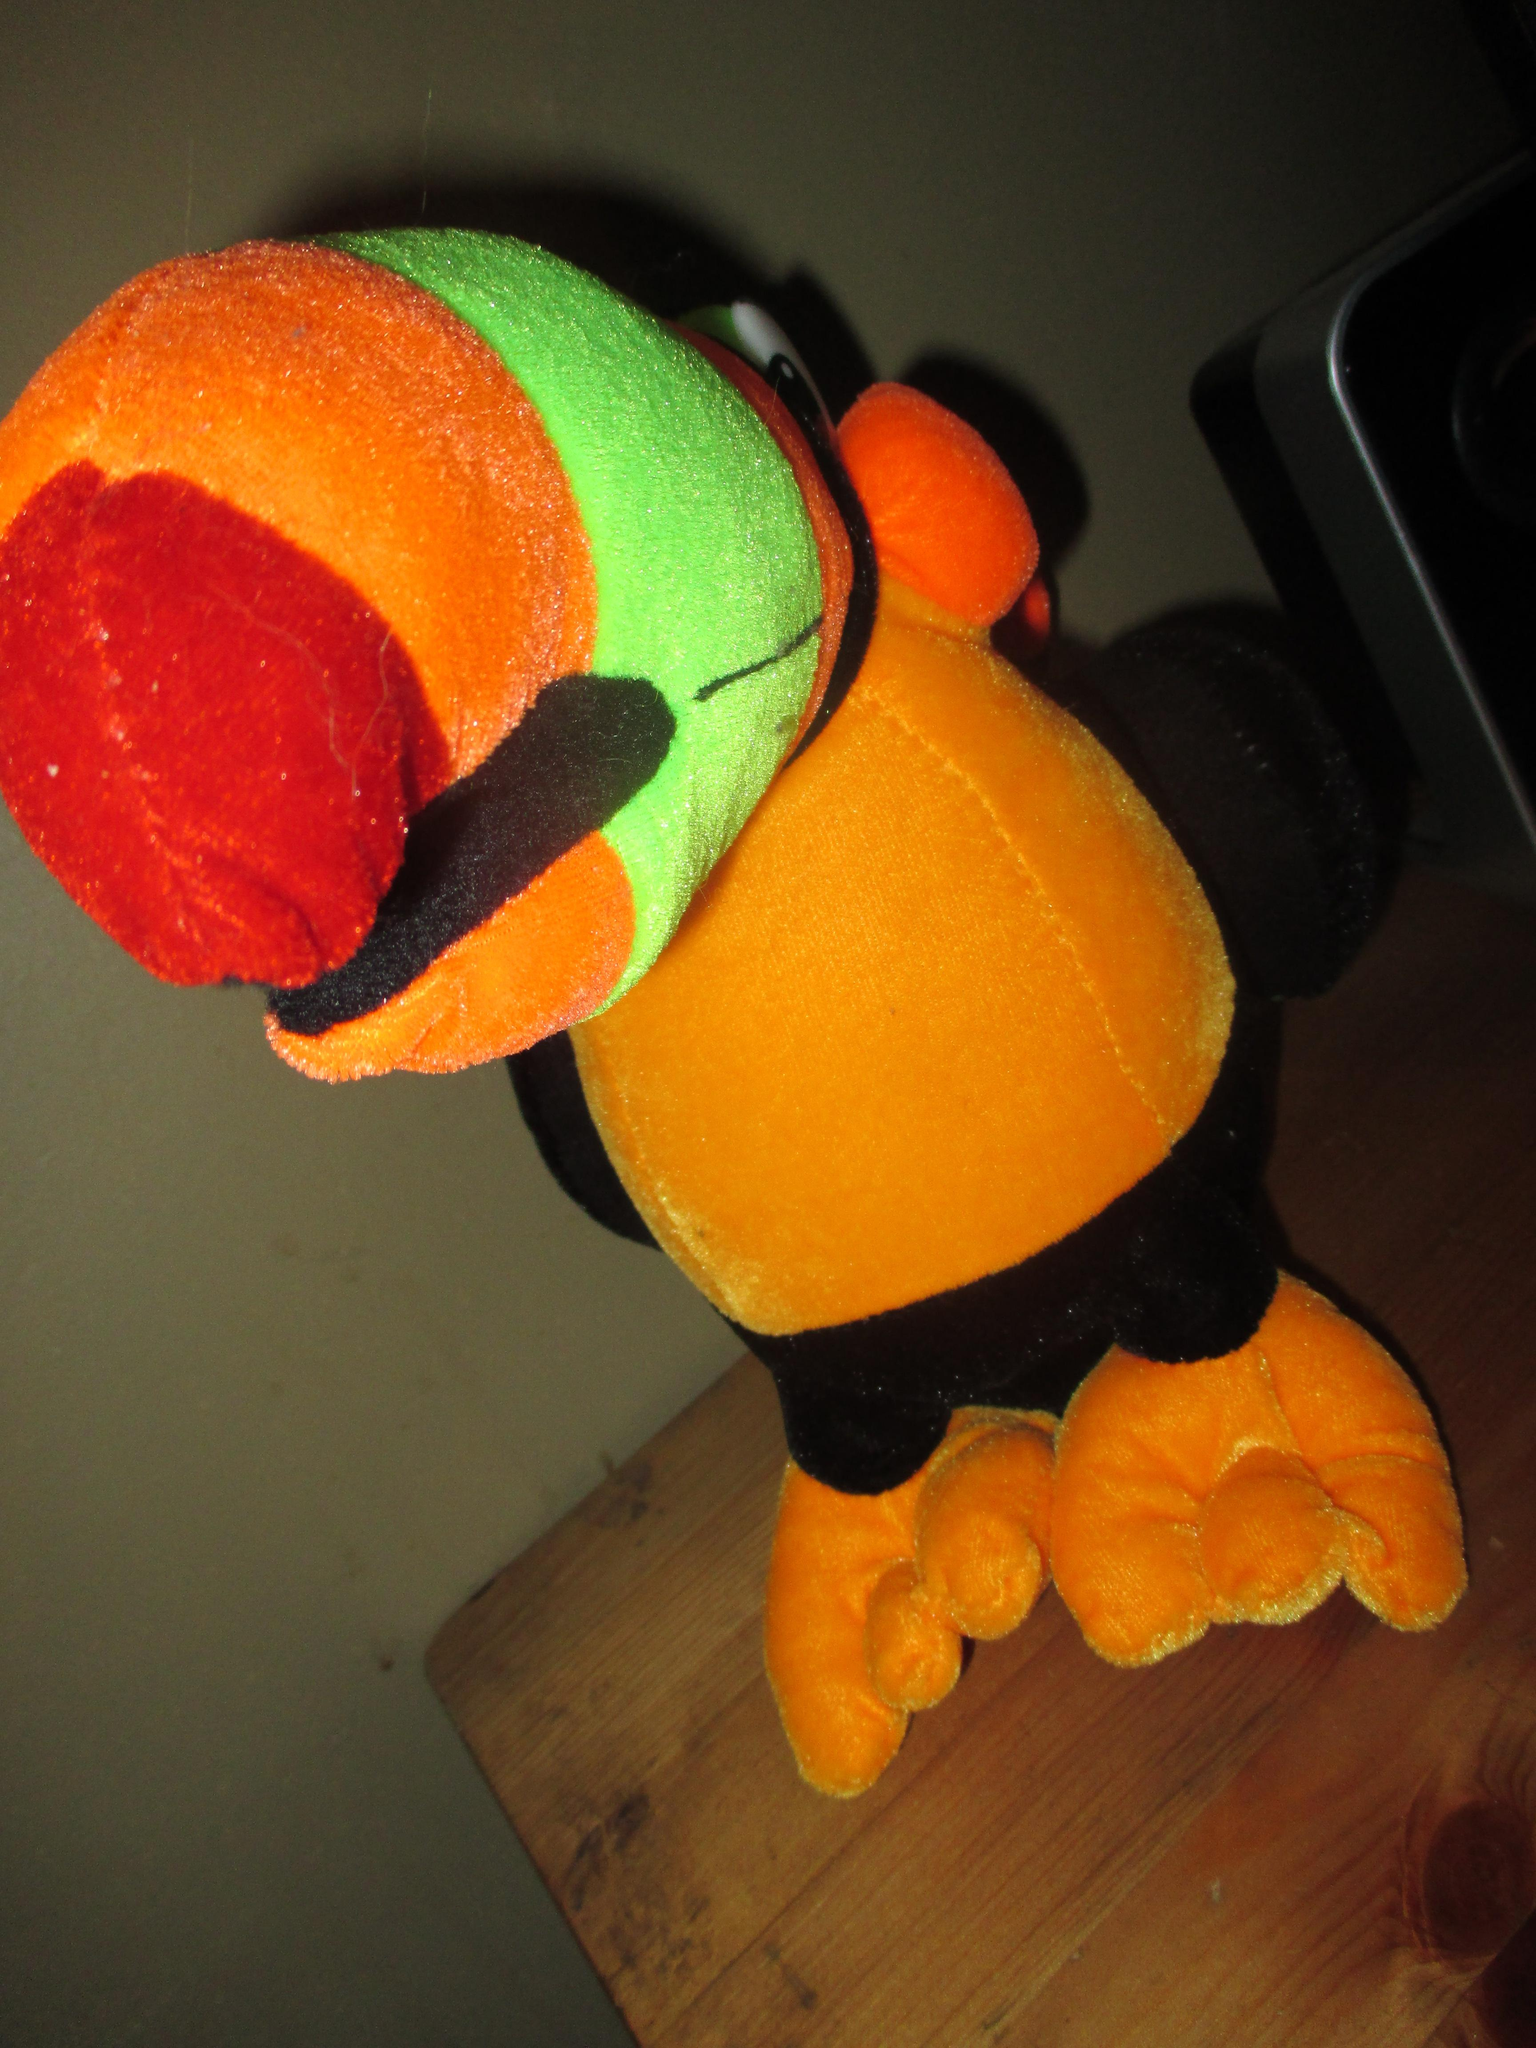What type of surface is visible in the image? There is a wooden surface in the image. What is placed on the wooden surface? There is a toy on the wooden surface. What other object can be seen in the image? There is an electronic device in the image. Can you see a river flowing in the background of the image? There is no river visible in the image; it only features a wooden surface, a toy, and an electronic device. Is there a coat hanging on the wooden surface in the image? There is no coat present in the image; it only features a wooden surface, a toy, and an electronic device. 